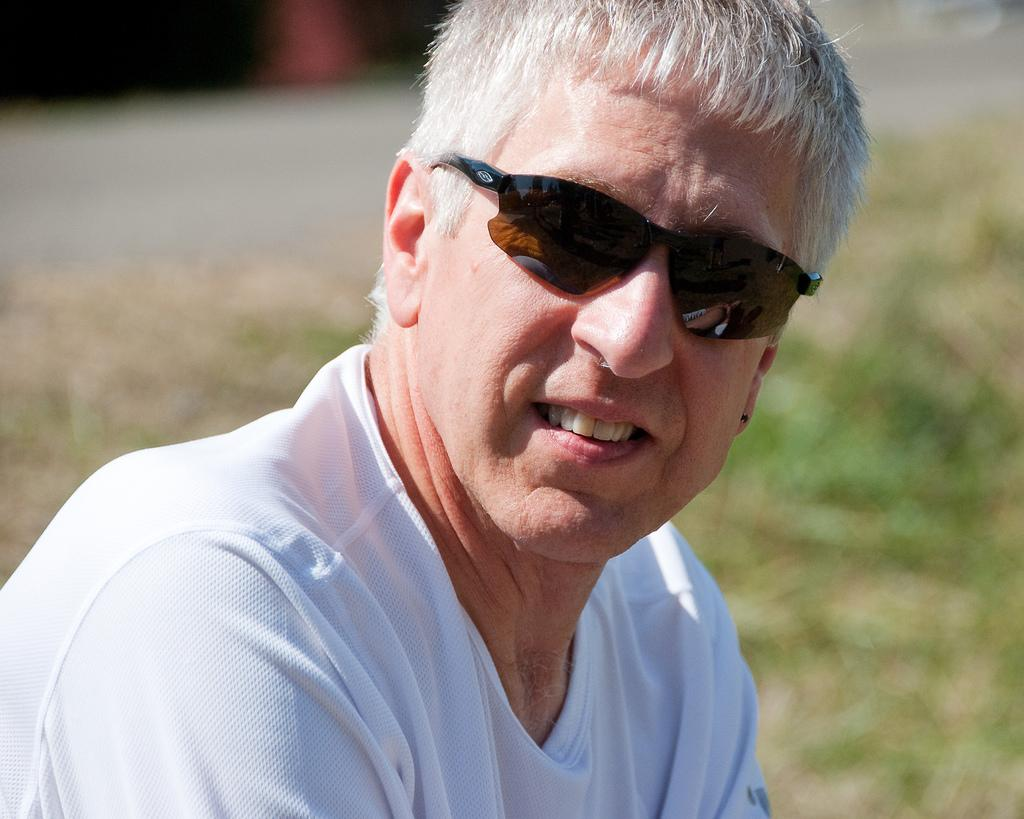What is present in the image? There is a man in the image. What type of natural environment can be seen in the background of the image? There is grass visible in the background of the image. What type of rod is the man using to sharpen his pencil in the image? There is no rod or pencil present in the image, and therefore no such activity can be observed. 